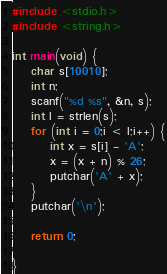Convert code to text. <code><loc_0><loc_0><loc_500><loc_500><_C_>#include <stdio.h>
#include <string.h>

int main(void) {
	char s[10010];
	int n;
	scanf("%d %s", &n, s);
	int l = strlen(s);
	for (int i = 0;i < l;i++) {
		int x = s[i] - 'A';
		x = (x + n) % 26;
		putchar('A' + x);
	}
	putchar('\n');

	return 0;

}</code> 